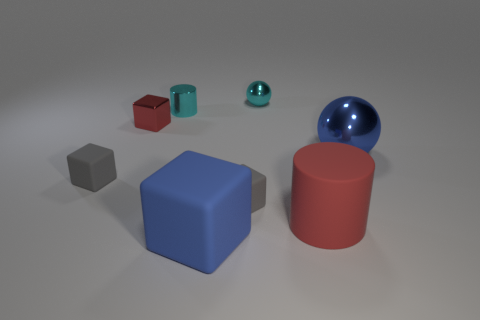Do the rubber cylinder and the small metallic cube have the same color?
Your answer should be compact. Yes. Are the big red thing and the big blue ball made of the same material?
Offer a very short reply. No. What number of tiny cyan shiny cylinders are behind the large blue matte thing?
Keep it short and to the point. 1. There is another cyan object that is the same shape as the big metal object; what is its size?
Your response must be concise. Small. How many red objects are either large cylinders or matte balls?
Provide a succinct answer. 1. What number of red rubber cylinders are left of the tiny cyan metallic cylinder that is on the left side of the red cylinder?
Offer a terse response. 0. How many other objects are there of the same shape as the blue rubber thing?
Keep it short and to the point. 3. There is a cylinder that is the same color as the metal cube; what is its material?
Your answer should be very brief. Rubber. What number of rubber cubes have the same color as the large metal ball?
Provide a short and direct response. 1. What is the color of the cylinder that is made of the same material as the small red cube?
Your answer should be very brief. Cyan. 